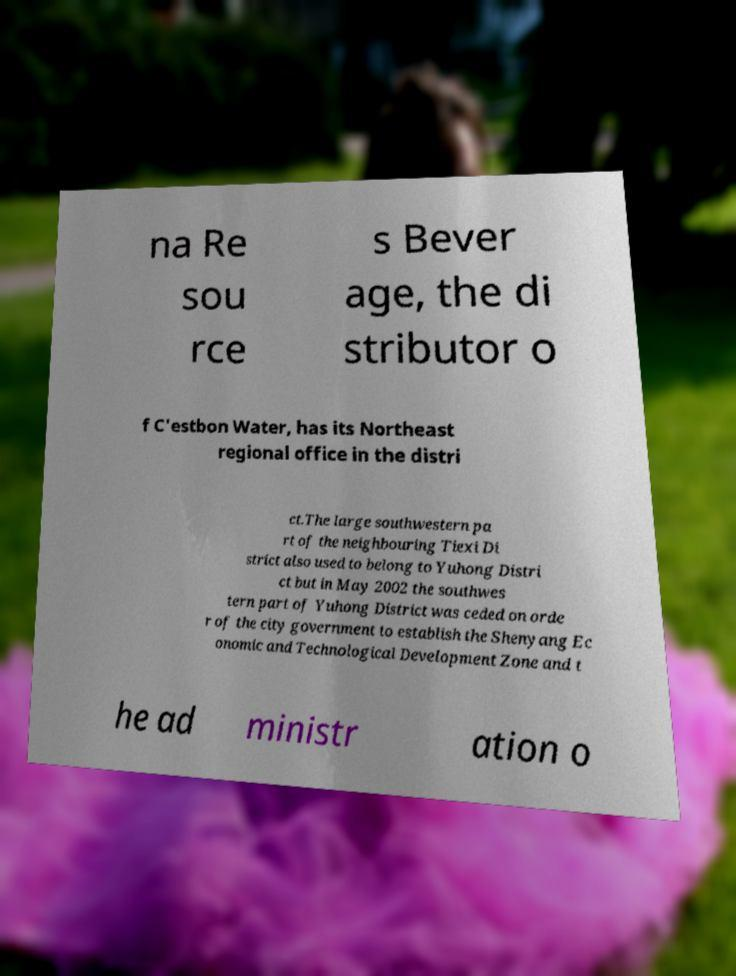What messages or text are displayed in this image? I need them in a readable, typed format. na Re sou rce s Bever age, the di stributor o f C'estbon Water, has its Northeast regional office in the distri ct.The large southwestern pa rt of the neighbouring Tiexi Di strict also used to belong to Yuhong Distri ct but in May 2002 the southwes tern part of Yuhong District was ceded on orde r of the city government to establish the Shenyang Ec onomic and Technological Development Zone and t he ad ministr ation o 